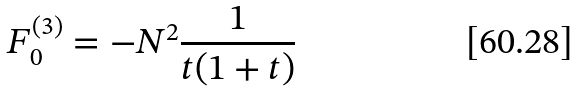Convert formula to latex. <formula><loc_0><loc_0><loc_500><loc_500>F _ { 0 } ^ { ( 3 ) } = - N ^ { 2 } \frac { 1 } { t ( 1 + t ) }</formula> 